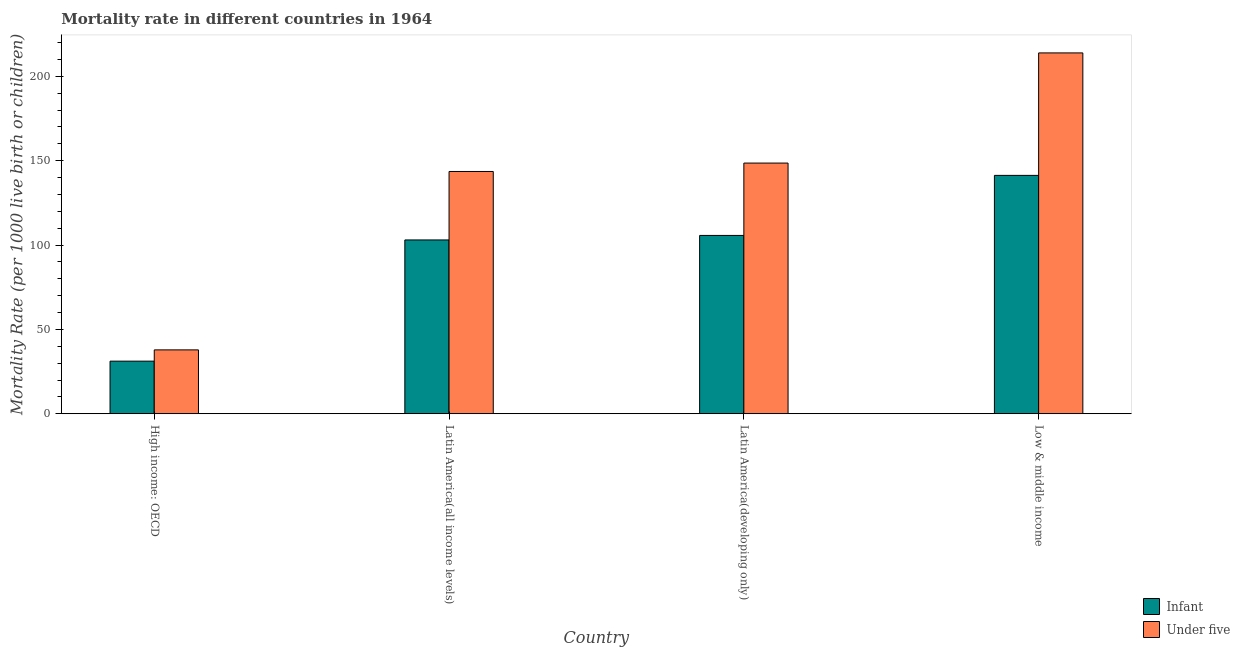Are the number of bars on each tick of the X-axis equal?
Make the answer very short. Yes. How many bars are there on the 1st tick from the left?
Provide a short and direct response. 2. What is the label of the 2nd group of bars from the left?
Your answer should be very brief. Latin America(all income levels). In how many cases, is the number of bars for a given country not equal to the number of legend labels?
Ensure brevity in your answer.  0. What is the under-5 mortality rate in Low & middle income?
Your answer should be very brief. 213.9. Across all countries, what is the maximum infant mortality rate?
Your response must be concise. 141.3. Across all countries, what is the minimum under-5 mortality rate?
Make the answer very short. 37.85. In which country was the infant mortality rate maximum?
Keep it short and to the point. Low & middle income. In which country was the under-5 mortality rate minimum?
Provide a succinct answer. High income: OECD. What is the total under-5 mortality rate in the graph?
Offer a terse response. 543.97. What is the difference between the under-5 mortality rate in High income: OECD and that in Low & middle income?
Your answer should be compact. -176.05. What is the difference between the infant mortality rate in High income: OECD and the under-5 mortality rate in Low & middle income?
Your answer should be very brief. -182.73. What is the average infant mortality rate per country?
Give a very brief answer. 95.3. What is the difference between the infant mortality rate and under-5 mortality rate in High income: OECD?
Offer a very short reply. -6.68. In how many countries, is the under-5 mortality rate greater than 90 ?
Ensure brevity in your answer.  3. What is the ratio of the under-5 mortality rate in Latin America(all income levels) to that in Latin America(developing only)?
Keep it short and to the point. 0.97. Is the under-5 mortality rate in High income: OECD less than that in Latin America(developing only)?
Offer a very short reply. Yes. Is the difference between the infant mortality rate in High income: OECD and Latin America(developing only) greater than the difference between the under-5 mortality rate in High income: OECD and Latin America(developing only)?
Make the answer very short. Yes. What is the difference between the highest and the second highest infant mortality rate?
Keep it short and to the point. 35.6. What is the difference between the highest and the lowest infant mortality rate?
Offer a terse response. 110.13. What does the 2nd bar from the left in Low & middle income represents?
Your response must be concise. Under five. What does the 1st bar from the right in Low & middle income represents?
Make the answer very short. Under five. How many bars are there?
Offer a terse response. 8. Does the graph contain any zero values?
Offer a terse response. No. Where does the legend appear in the graph?
Give a very brief answer. Bottom right. How many legend labels are there?
Ensure brevity in your answer.  2. How are the legend labels stacked?
Make the answer very short. Vertical. What is the title of the graph?
Make the answer very short. Mortality rate in different countries in 1964. What is the label or title of the X-axis?
Offer a very short reply. Country. What is the label or title of the Y-axis?
Offer a very short reply. Mortality Rate (per 1000 live birth or children). What is the Mortality Rate (per 1000 live birth or children) of Infant in High income: OECD?
Provide a succinct answer. 31.17. What is the Mortality Rate (per 1000 live birth or children) in Under five in High income: OECD?
Give a very brief answer. 37.85. What is the Mortality Rate (per 1000 live birth or children) in Infant in Latin America(all income levels)?
Provide a succinct answer. 103.03. What is the Mortality Rate (per 1000 live birth or children) of Under five in Latin America(all income levels)?
Offer a terse response. 143.62. What is the Mortality Rate (per 1000 live birth or children) of Infant in Latin America(developing only)?
Make the answer very short. 105.7. What is the Mortality Rate (per 1000 live birth or children) of Under five in Latin America(developing only)?
Offer a terse response. 148.6. What is the Mortality Rate (per 1000 live birth or children) in Infant in Low & middle income?
Offer a terse response. 141.3. What is the Mortality Rate (per 1000 live birth or children) in Under five in Low & middle income?
Provide a succinct answer. 213.9. Across all countries, what is the maximum Mortality Rate (per 1000 live birth or children) in Infant?
Make the answer very short. 141.3. Across all countries, what is the maximum Mortality Rate (per 1000 live birth or children) in Under five?
Ensure brevity in your answer.  213.9. Across all countries, what is the minimum Mortality Rate (per 1000 live birth or children) in Infant?
Your response must be concise. 31.17. Across all countries, what is the minimum Mortality Rate (per 1000 live birth or children) of Under five?
Give a very brief answer. 37.85. What is the total Mortality Rate (per 1000 live birth or children) of Infant in the graph?
Offer a very short reply. 381.2. What is the total Mortality Rate (per 1000 live birth or children) in Under five in the graph?
Keep it short and to the point. 543.97. What is the difference between the Mortality Rate (per 1000 live birth or children) in Infant in High income: OECD and that in Latin America(all income levels)?
Provide a short and direct response. -71.86. What is the difference between the Mortality Rate (per 1000 live birth or children) of Under five in High income: OECD and that in Latin America(all income levels)?
Ensure brevity in your answer.  -105.77. What is the difference between the Mortality Rate (per 1000 live birth or children) of Infant in High income: OECD and that in Latin America(developing only)?
Offer a terse response. -74.53. What is the difference between the Mortality Rate (per 1000 live birth or children) in Under five in High income: OECD and that in Latin America(developing only)?
Provide a succinct answer. -110.75. What is the difference between the Mortality Rate (per 1000 live birth or children) of Infant in High income: OECD and that in Low & middle income?
Give a very brief answer. -110.13. What is the difference between the Mortality Rate (per 1000 live birth or children) of Under five in High income: OECD and that in Low & middle income?
Your answer should be compact. -176.05. What is the difference between the Mortality Rate (per 1000 live birth or children) of Infant in Latin America(all income levels) and that in Latin America(developing only)?
Give a very brief answer. -2.67. What is the difference between the Mortality Rate (per 1000 live birth or children) of Under five in Latin America(all income levels) and that in Latin America(developing only)?
Ensure brevity in your answer.  -4.98. What is the difference between the Mortality Rate (per 1000 live birth or children) of Infant in Latin America(all income levels) and that in Low & middle income?
Your answer should be compact. -38.27. What is the difference between the Mortality Rate (per 1000 live birth or children) in Under five in Latin America(all income levels) and that in Low & middle income?
Your answer should be compact. -70.28. What is the difference between the Mortality Rate (per 1000 live birth or children) in Infant in Latin America(developing only) and that in Low & middle income?
Make the answer very short. -35.6. What is the difference between the Mortality Rate (per 1000 live birth or children) in Under five in Latin America(developing only) and that in Low & middle income?
Offer a terse response. -65.3. What is the difference between the Mortality Rate (per 1000 live birth or children) in Infant in High income: OECD and the Mortality Rate (per 1000 live birth or children) in Under five in Latin America(all income levels)?
Ensure brevity in your answer.  -112.44. What is the difference between the Mortality Rate (per 1000 live birth or children) in Infant in High income: OECD and the Mortality Rate (per 1000 live birth or children) in Under five in Latin America(developing only)?
Your answer should be very brief. -117.43. What is the difference between the Mortality Rate (per 1000 live birth or children) of Infant in High income: OECD and the Mortality Rate (per 1000 live birth or children) of Under five in Low & middle income?
Give a very brief answer. -182.73. What is the difference between the Mortality Rate (per 1000 live birth or children) in Infant in Latin America(all income levels) and the Mortality Rate (per 1000 live birth or children) in Under five in Latin America(developing only)?
Your answer should be compact. -45.57. What is the difference between the Mortality Rate (per 1000 live birth or children) of Infant in Latin America(all income levels) and the Mortality Rate (per 1000 live birth or children) of Under five in Low & middle income?
Your answer should be very brief. -110.87. What is the difference between the Mortality Rate (per 1000 live birth or children) of Infant in Latin America(developing only) and the Mortality Rate (per 1000 live birth or children) of Under five in Low & middle income?
Ensure brevity in your answer.  -108.2. What is the average Mortality Rate (per 1000 live birth or children) of Infant per country?
Provide a succinct answer. 95.3. What is the average Mortality Rate (per 1000 live birth or children) of Under five per country?
Your answer should be very brief. 135.99. What is the difference between the Mortality Rate (per 1000 live birth or children) of Infant and Mortality Rate (per 1000 live birth or children) of Under five in High income: OECD?
Provide a succinct answer. -6.68. What is the difference between the Mortality Rate (per 1000 live birth or children) of Infant and Mortality Rate (per 1000 live birth or children) of Under five in Latin America(all income levels)?
Your answer should be very brief. -40.59. What is the difference between the Mortality Rate (per 1000 live birth or children) in Infant and Mortality Rate (per 1000 live birth or children) in Under five in Latin America(developing only)?
Your answer should be very brief. -42.9. What is the difference between the Mortality Rate (per 1000 live birth or children) in Infant and Mortality Rate (per 1000 live birth or children) in Under five in Low & middle income?
Your response must be concise. -72.6. What is the ratio of the Mortality Rate (per 1000 live birth or children) in Infant in High income: OECD to that in Latin America(all income levels)?
Offer a terse response. 0.3. What is the ratio of the Mortality Rate (per 1000 live birth or children) in Under five in High income: OECD to that in Latin America(all income levels)?
Offer a terse response. 0.26. What is the ratio of the Mortality Rate (per 1000 live birth or children) of Infant in High income: OECD to that in Latin America(developing only)?
Your response must be concise. 0.29. What is the ratio of the Mortality Rate (per 1000 live birth or children) of Under five in High income: OECD to that in Latin America(developing only)?
Make the answer very short. 0.25. What is the ratio of the Mortality Rate (per 1000 live birth or children) in Infant in High income: OECD to that in Low & middle income?
Your response must be concise. 0.22. What is the ratio of the Mortality Rate (per 1000 live birth or children) in Under five in High income: OECD to that in Low & middle income?
Make the answer very short. 0.18. What is the ratio of the Mortality Rate (per 1000 live birth or children) of Infant in Latin America(all income levels) to that in Latin America(developing only)?
Make the answer very short. 0.97. What is the ratio of the Mortality Rate (per 1000 live birth or children) of Under five in Latin America(all income levels) to that in Latin America(developing only)?
Give a very brief answer. 0.97. What is the ratio of the Mortality Rate (per 1000 live birth or children) in Infant in Latin America(all income levels) to that in Low & middle income?
Give a very brief answer. 0.73. What is the ratio of the Mortality Rate (per 1000 live birth or children) of Under five in Latin America(all income levels) to that in Low & middle income?
Make the answer very short. 0.67. What is the ratio of the Mortality Rate (per 1000 live birth or children) of Infant in Latin America(developing only) to that in Low & middle income?
Offer a terse response. 0.75. What is the ratio of the Mortality Rate (per 1000 live birth or children) of Under five in Latin America(developing only) to that in Low & middle income?
Your response must be concise. 0.69. What is the difference between the highest and the second highest Mortality Rate (per 1000 live birth or children) in Infant?
Give a very brief answer. 35.6. What is the difference between the highest and the second highest Mortality Rate (per 1000 live birth or children) in Under five?
Give a very brief answer. 65.3. What is the difference between the highest and the lowest Mortality Rate (per 1000 live birth or children) in Infant?
Provide a succinct answer. 110.13. What is the difference between the highest and the lowest Mortality Rate (per 1000 live birth or children) in Under five?
Give a very brief answer. 176.05. 